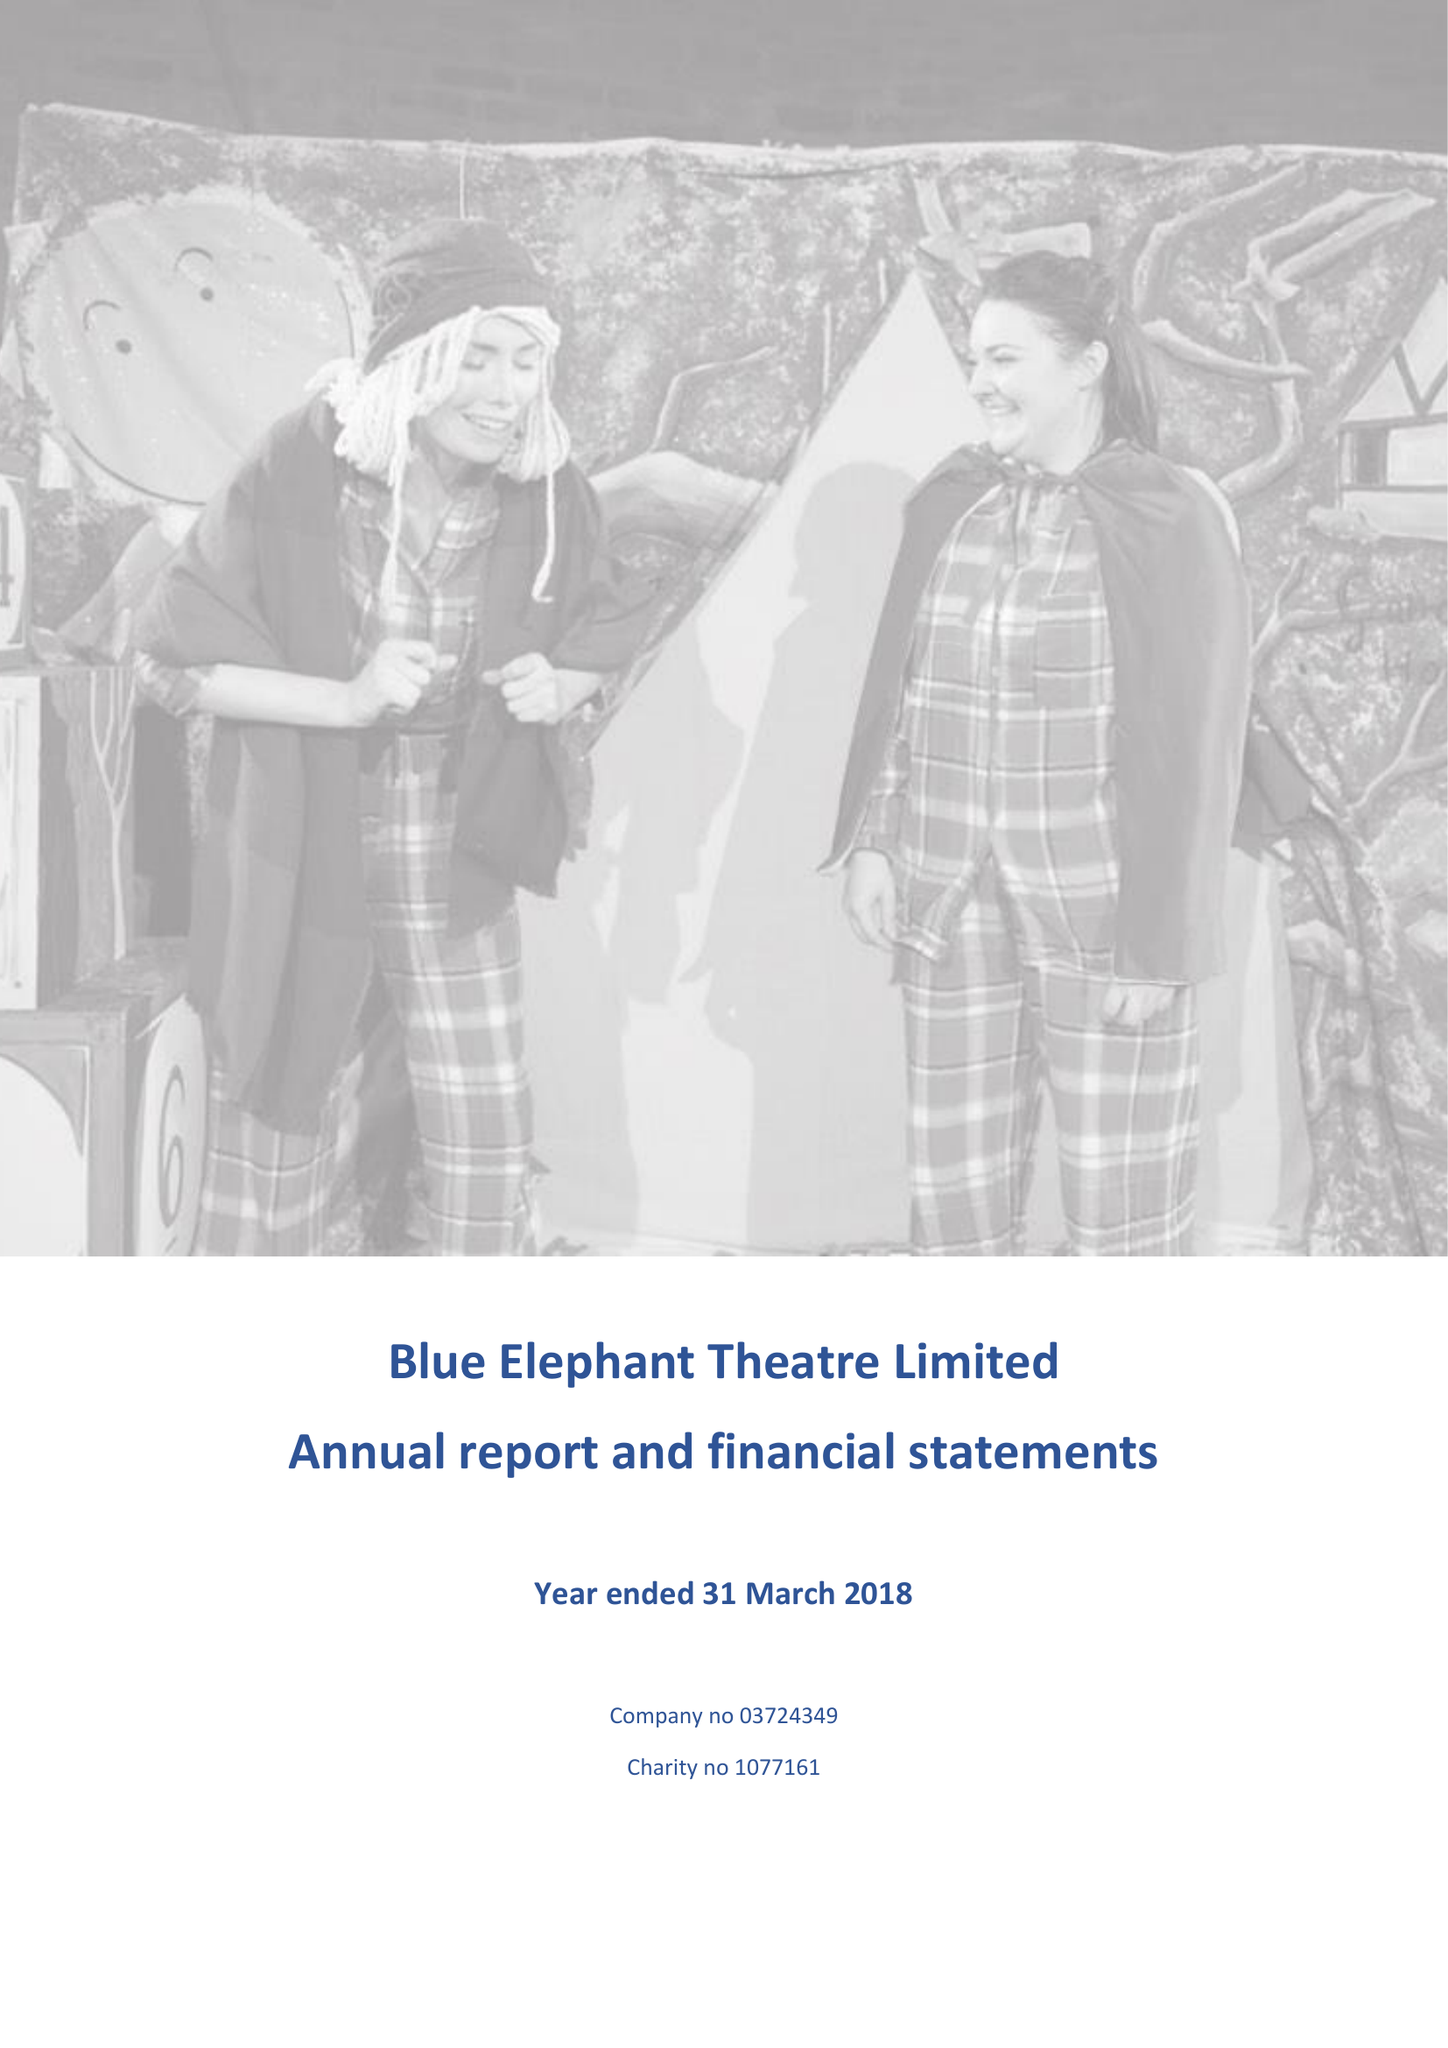What is the value for the charity_name?
Answer the question using a single word or phrase. Blue Elephant Theatre Ltd. 